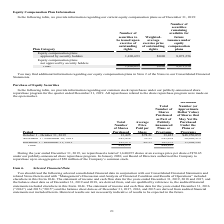According to Manhattan Associates's financial document, How many shares are repurchased in 2019 October? According to the financial document, 13,425. The relevant text states: "October 1 - October 31, 2019 13,425 $78.21 13,425 $48,950,059..." Also, What is the average repurchase price paid per share for 2019 December? According to the financial document, 80.95. The relevant text states: "December 1 - December 31, 2019 185,973 80.95 185,973 15,008,242..." Also, What is the amount of share repurchase authorised by the board of directors in Janurary 2020? According to the financial document, $50 million. The relevant text states: "ed the Company to repurchase up to an aggregate of $50 million of the Company’s common stock. Item 6. Selected Financial Data..." Also, can you calculate: What is the amount of money used for share repurchase in 2019 October? Based on the calculation: 13,425*$78.21, the result is 1049969.25. This is based on the information: "October 1 - October 31, 2019 13,425 $78.21 13,425 $48,950,059 October 1 - October 31, 2019 13,425 $78.21 13,425 $48,950,059..." The key data points involved are: 13,425, 78.21. Additionally, Which period has the highest total number of shares purchased? November 1 - November 30, 2019. The document states: "November 1 - November 30, 2019 245,454 76.95 245,454 30,062,919..." Also, can you calculate: What is the difference in the total number of shares purchased between November and December? Based on the calculation: 245,454-185,973, the result is 59481. This is based on the information: "December 1 - December 31, 2019 185,973 80.95 185,973 15,008,242 November 1 - November 30, 2019 245,454 76.95 245,454 30,062,919..." The key data points involved are: 185,973, 245,454. 